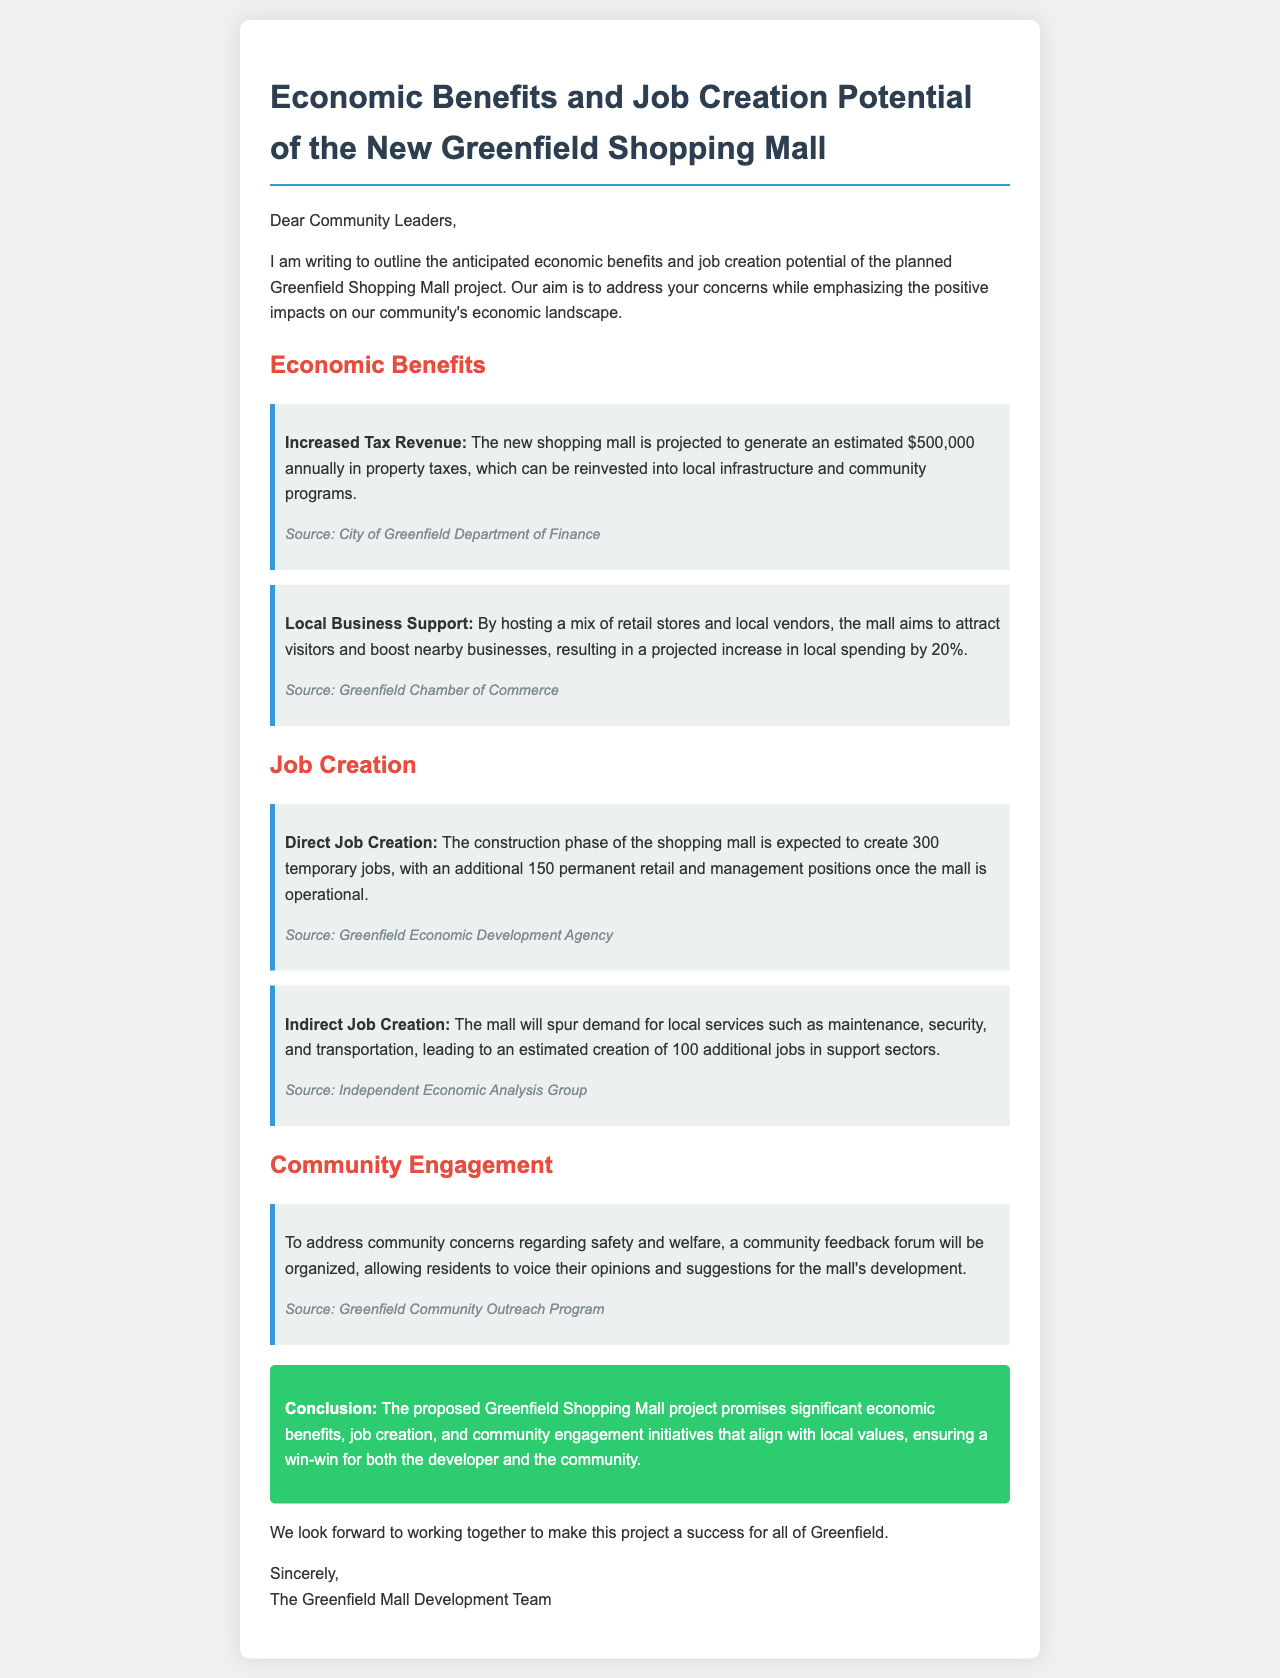What is the annual property tax revenue projected? The project outlines an estimated annual property tax revenue of $500,000.
Answer: $500,000 How many temporary jobs will be created during construction? The document states that the construction phase is expected to create 300 temporary jobs.
Answer: 300 What percentage increase in local spending is projected? The document mentions a projected increase in local spending by 20%.
Answer: 20% What type of jobs will be created after the mall is operational? The proposal indicates that there will be 150 permanent retail and management positions once the mall is operational.
Answer: 150 What initiative will be organized to address community concerns? The document specifies that a community feedback forum will be organized for residents to voice their opinions.
Answer: community feedback forum What does the proposal aim to achieve with local businesses? The proposal aims to support local businesses by attracting visitors and boosting nearby business.
Answer: boost nearby businesses What type of document is this proposal? This document is a project proposal outlining economic benefits and job creation potential.
Answer: project proposal How many indirect jobs are expected to be created? The document estimates the creation of 100 additional jobs in support sectors.
Answer: 100 What color represents the conclusion section in the document? The conclusion section is indicated to have a background color of green, specifically #2ecc71.
Answer: green 